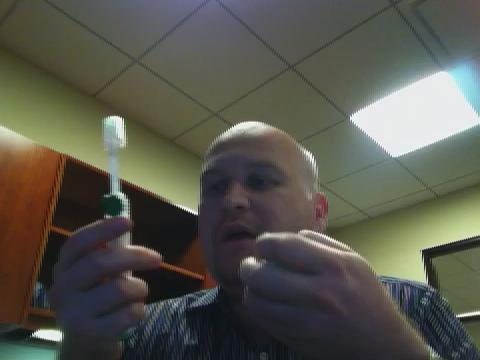How many toothbrushes are in the photo?
Give a very brief answer. 1. How many men are in the picture?
Give a very brief answer. 1. How many oranges in the plate?
Give a very brief answer. 0. 